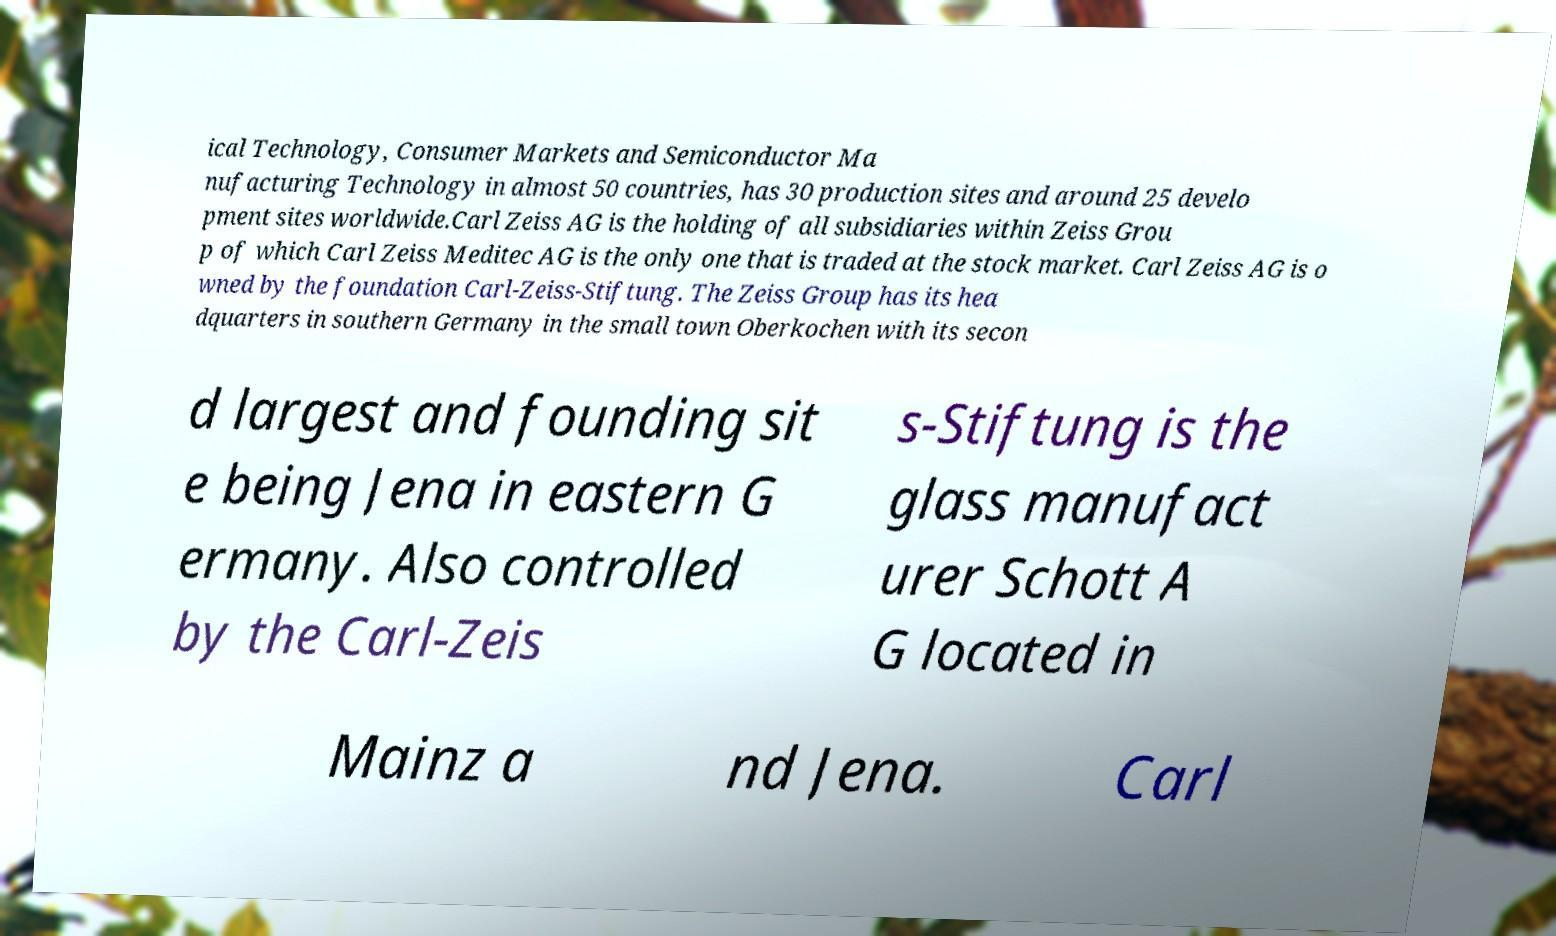For documentation purposes, I need the text within this image transcribed. Could you provide that? ical Technology, Consumer Markets and Semiconductor Ma nufacturing Technology in almost 50 countries, has 30 production sites and around 25 develo pment sites worldwide.Carl Zeiss AG is the holding of all subsidiaries within Zeiss Grou p of which Carl Zeiss Meditec AG is the only one that is traded at the stock market. Carl Zeiss AG is o wned by the foundation Carl-Zeiss-Stiftung. The Zeiss Group has its hea dquarters in southern Germany in the small town Oberkochen with its secon d largest and founding sit e being Jena in eastern G ermany. Also controlled by the Carl-Zeis s-Stiftung is the glass manufact urer Schott A G located in Mainz a nd Jena. Carl 